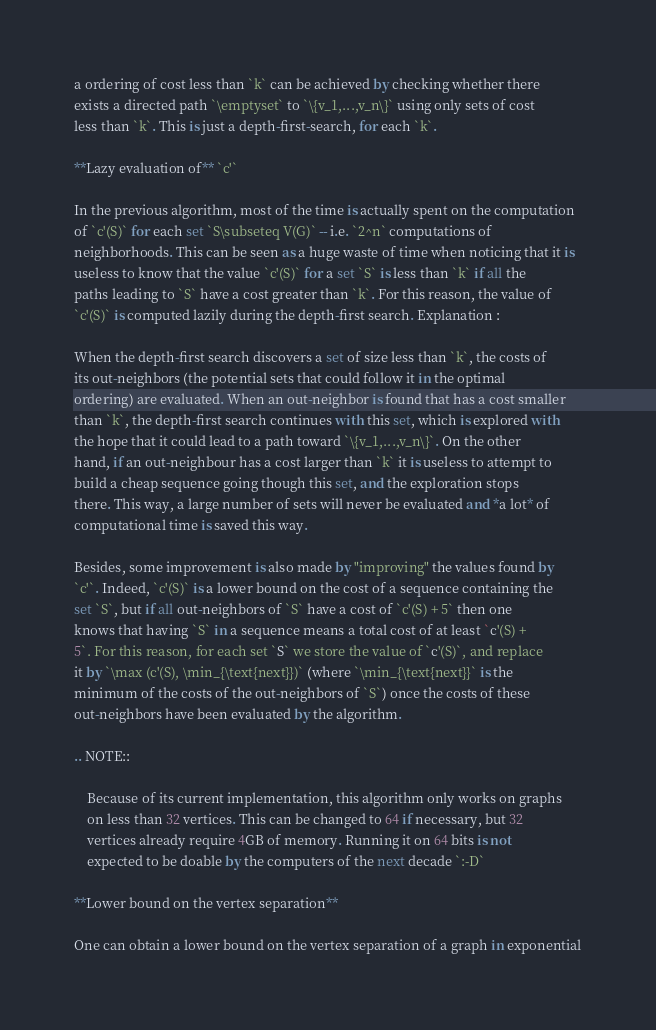Convert code to text. <code><loc_0><loc_0><loc_500><loc_500><_Cython_>a ordering of cost less than `k` can be achieved by checking whether there
exists a directed path `\emptyset` to `\{v_1,...,v_n\}` using only sets of cost
less than `k`. This is just a depth-first-search, for each `k`.

**Lazy evaluation of** `c'`

In the previous algorithm, most of the time is actually spent on the computation
of `c'(S)` for each set `S\subseteq V(G)` -- i.e. `2^n` computations of
neighborhoods. This can be seen as a huge waste of time when noticing that it is
useless to know that the value `c'(S)` for a set `S` is less than `k` if all the
paths leading to `S` have a cost greater than `k`. For this reason, the value of
`c'(S)` is computed lazily during the depth-first search. Explanation :

When the depth-first search discovers a set of size less than `k`, the costs of
its out-neighbors (the potential sets that could follow it in the optimal
ordering) are evaluated. When an out-neighbor is found that has a cost smaller
than `k`, the depth-first search continues with this set, which is explored with
the hope that it could lead to a path toward `\{v_1,...,v_n\}`. On the other
hand, if an out-neighbour has a cost larger than `k` it is useless to attempt to
build a cheap sequence going though this set, and the exploration stops
there. This way, a large number of sets will never be evaluated and *a lot* of
computational time is saved this way.

Besides, some improvement is also made by "improving" the values found by
`c'`. Indeed, `c'(S)` is a lower bound on the cost of a sequence containing the
set `S`, but if all out-neighbors of `S` have a cost of `c'(S) + 5` then one
knows that having `S` in a sequence means a total cost of at least `c'(S) +
5`. For this reason, for each set `S` we store the value of `c'(S)`, and replace
it by `\max (c'(S), \min_{\text{next}})` (where `\min_{\text{next}}` is the
minimum of the costs of the out-neighbors of `S`) once the costs of these
out-neighbors have been evaluated by the algorithm.

.. NOTE::

    Because of its current implementation, this algorithm only works on graphs
    on less than 32 vertices. This can be changed to 64 if necessary, but 32
    vertices already require 4GB of memory. Running it on 64 bits is not
    expected to be doable by the computers of the next decade `:-D`

**Lower bound on the vertex separation**

One can obtain a lower bound on the vertex separation of a graph in exponential</code> 